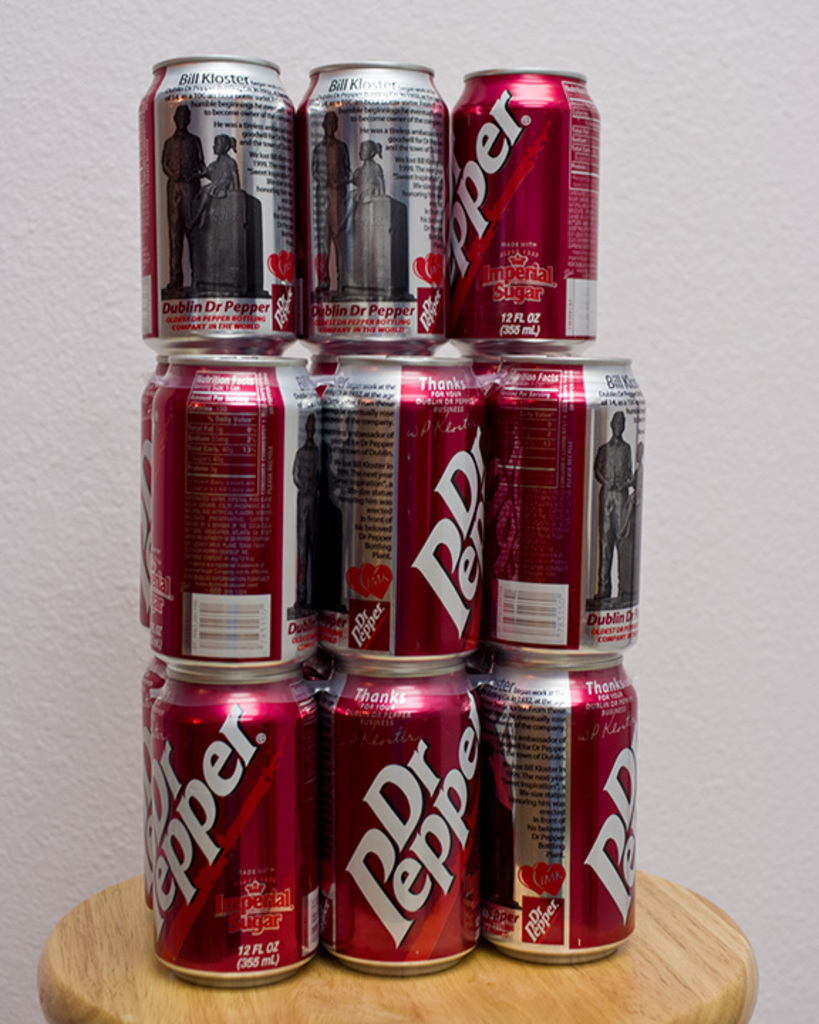Can you describe any historical significance related to the 'Dublin Dr Pepper' variant featured on these cans? The 'Dublin Dr Pepper' variant, produced in Dublin, Texas, was famed for sticking to the original Dr Pepper formula that used cane sugar. This practice continued for years even as other manufacturers shifted to cheaper sweeteners, making it highly valued for its authenticity and connection to Dr Pepper's historical roots. 